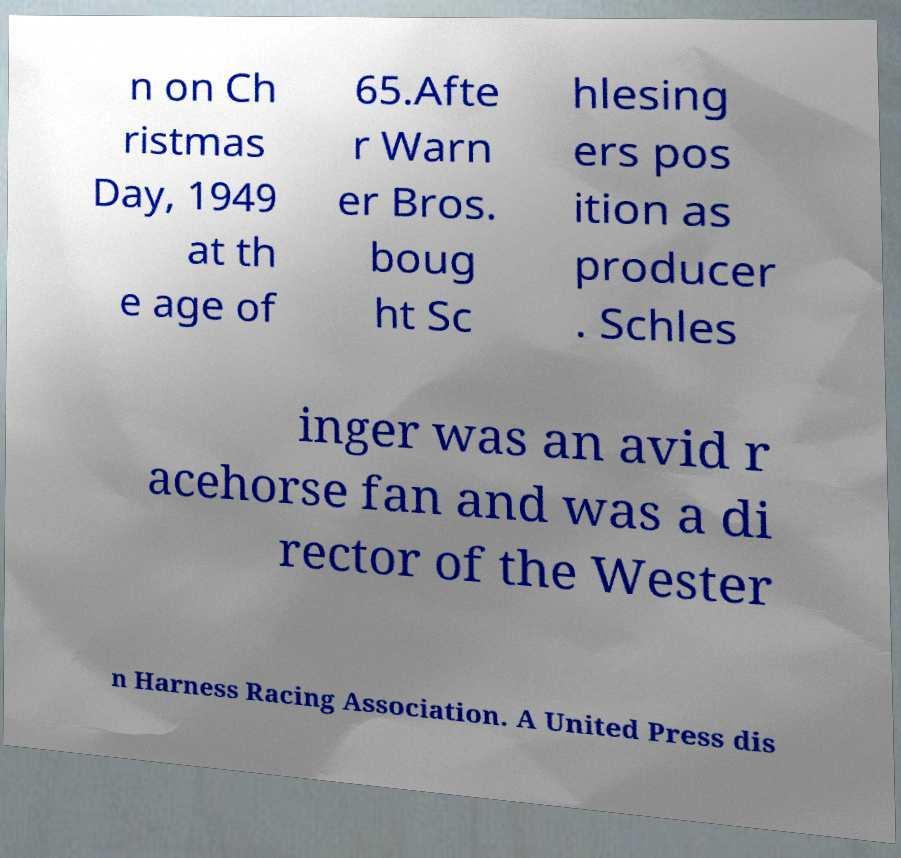Please read and relay the text visible in this image. What does it say? n on Ch ristmas Day, 1949 at th e age of 65.Afte r Warn er Bros. boug ht Sc hlesing ers pos ition as producer . Schles inger was an avid r acehorse fan and was a di rector of the Wester n Harness Racing Association. A United Press dis 